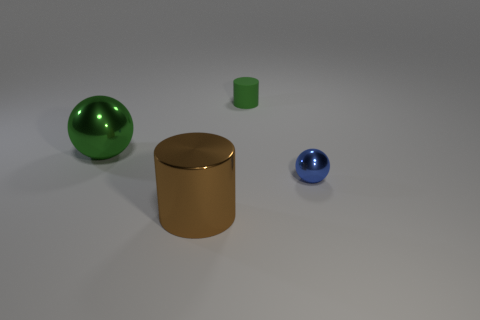Is there any other thing that has the same material as the small green cylinder?
Your answer should be very brief. No. There is a green object that is behind the thing to the left of the brown metal cylinder right of the large green shiny thing; what is its size?
Give a very brief answer. Small. Does the cylinder in front of the tiny green thing have the same material as the small blue sphere?
Offer a terse response. Yes. There is a sphere that is the same color as the rubber thing; what is it made of?
Provide a short and direct response. Metal. Is there any other thing that is the same shape as the blue object?
Provide a short and direct response. Yes. What number of objects are big gray objects or small things?
Provide a short and direct response. 2. The green thing that is the same shape as the blue metallic thing is what size?
Provide a succinct answer. Large. Are there any other things that are the same size as the brown metallic cylinder?
Your response must be concise. Yes. What number of other objects are there of the same color as the large shiny cylinder?
Your answer should be compact. 0. What number of cylinders are either large metallic objects or tiny green rubber things?
Make the answer very short. 2. 